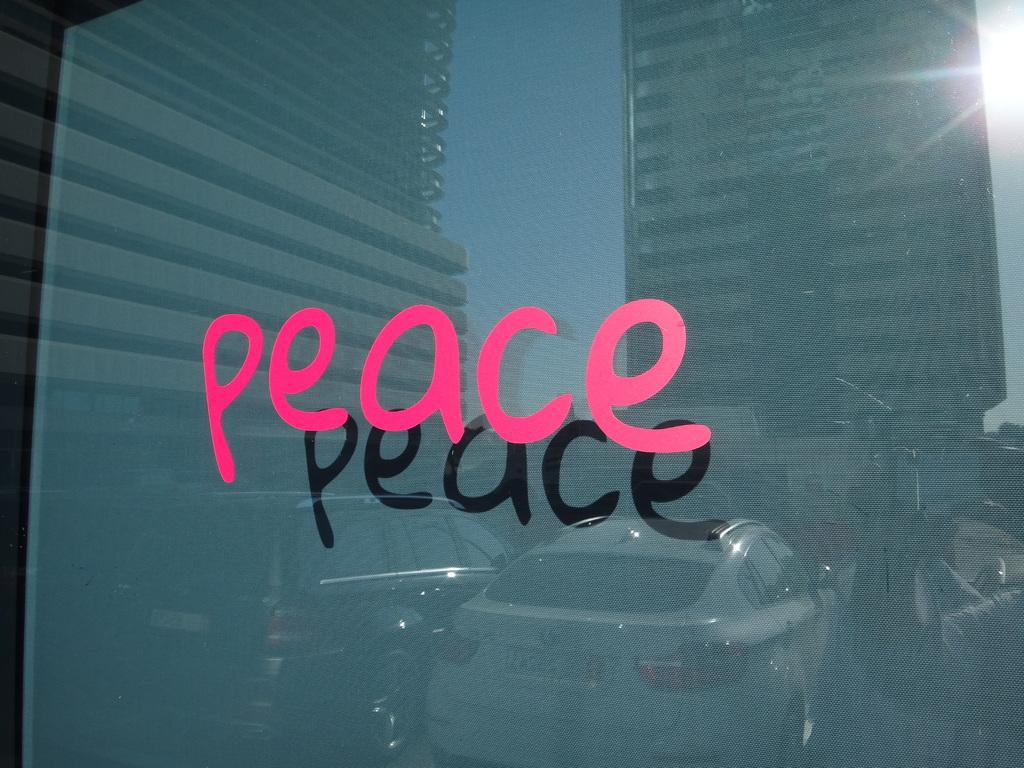What is written on the glass in the image? There is text written on the glass. What can be seen reflected in the glass? The glass reflects buildings, the sky, vehicles, and a few persons. Can you describe the types of objects reflected in the glass? The glass reflects buildings, the sky, vehicles, and a few persons. Can you see a band playing near the lake in the image? There is no band or lake present in the image; it only features reflections of buildings, the sky, vehicles, and a few persons. 